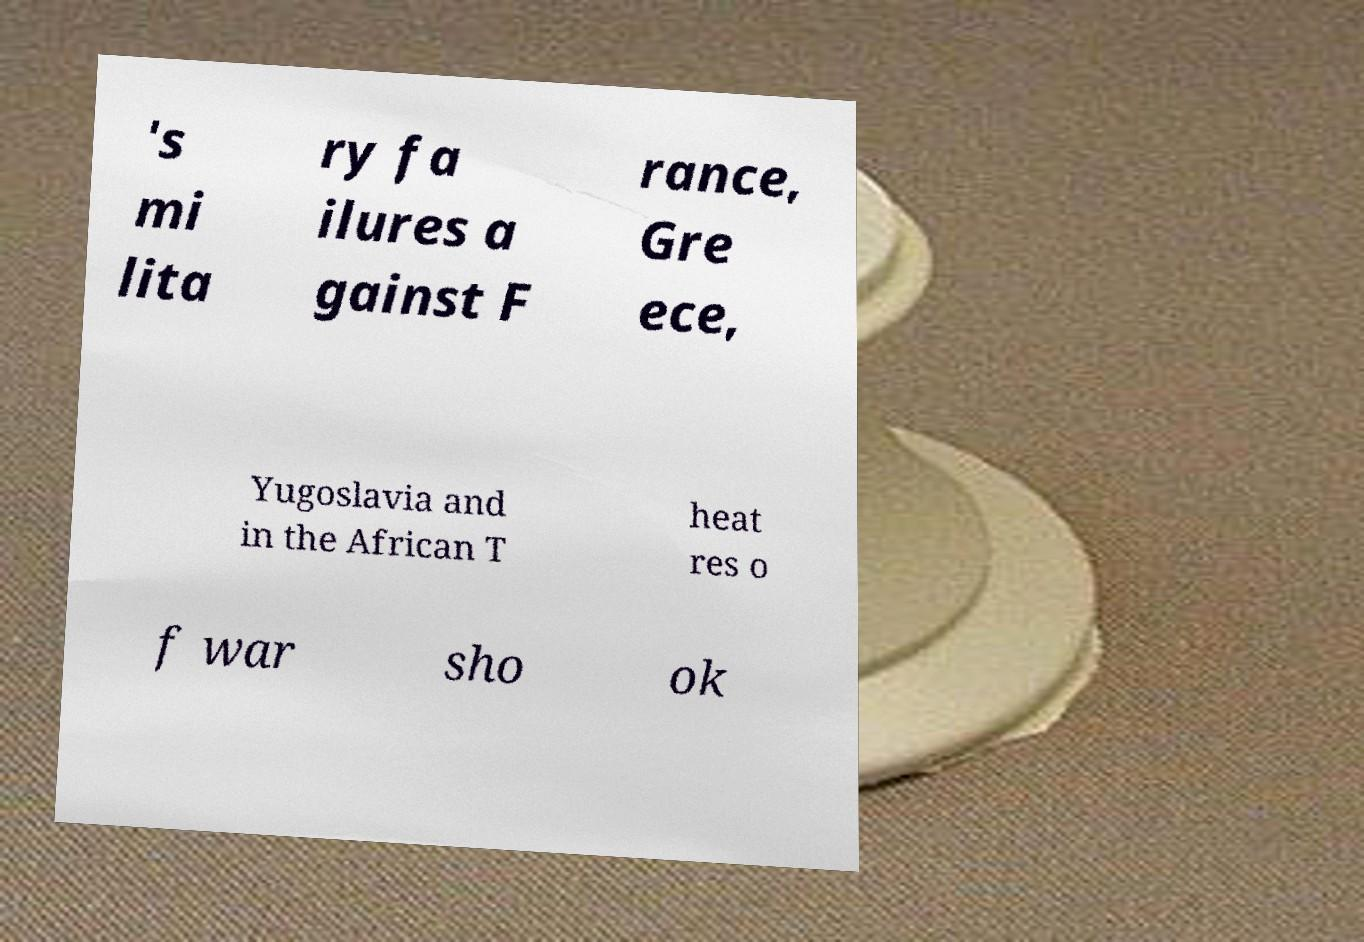Could you assist in decoding the text presented in this image and type it out clearly? 's mi lita ry fa ilures a gainst F rance, Gre ece, Yugoslavia and in the African T heat res o f war sho ok 